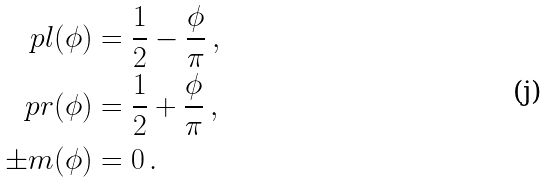Convert formula to latex. <formula><loc_0><loc_0><loc_500><loc_500>\ p l ( \phi ) & = \frac { 1 } { 2 } - \frac { \phi } { \pi } \, , \\ \ p r ( \phi ) & = \frac { 1 } { 2 } + \frac { \phi } { \pi } \, , \\ \pm m ( \phi ) & = 0 \, .</formula> 